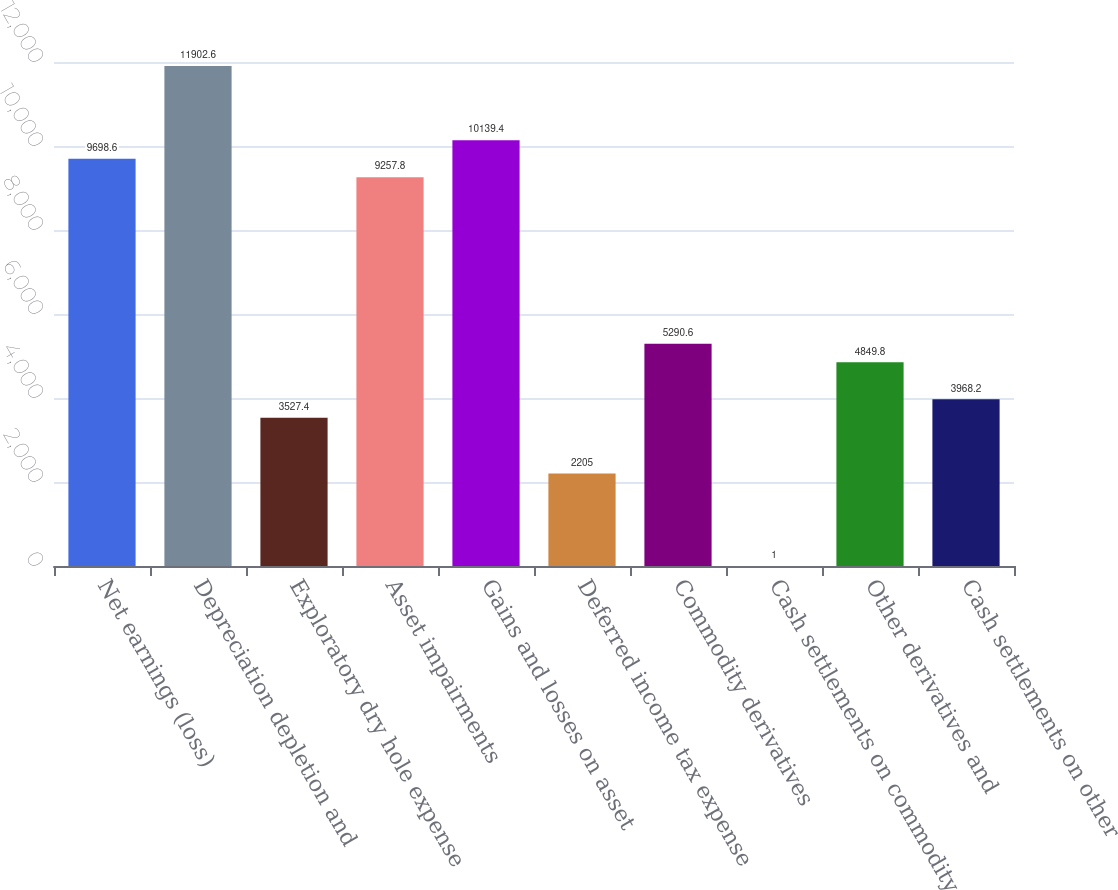<chart> <loc_0><loc_0><loc_500><loc_500><bar_chart><fcel>Net earnings (loss)<fcel>Depreciation depletion and<fcel>Exploratory dry hole expense<fcel>Asset impairments<fcel>Gains and losses on asset<fcel>Deferred income tax expense<fcel>Commodity derivatives<fcel>Cash settlements on commodity<fcel>Other derivatives and<fcel>Cash settlements on other<nl><fcel>9698.6<fcel>11902.6<fcel>3527.4<fcel>9257.8<fcel>10139.4<fcel>2205<fcel>5290.6<fcel>1<fcel>4849.8<fcel>3968.2<nl></chart> 